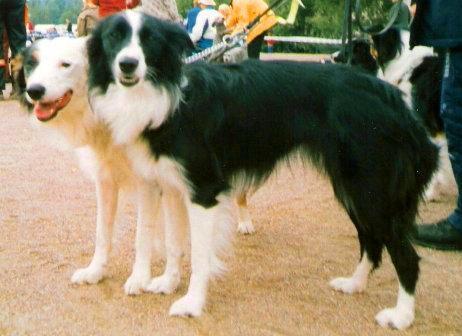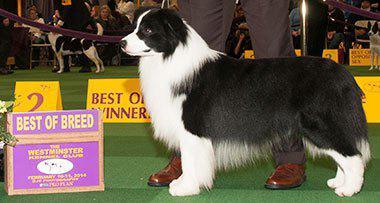The first image is the image on the left, the second image is the image on the right. Given the left and right images, does the statement "One image contains four or more dogs that are grouped together in a pose." hold true? Answer yes or no. No. The first image is the image on the left, the second image is the image on the right. Examine the images to the left and right. Is the description "Some of the dogs are sitting down." accurate? Answer yes or no. No. 